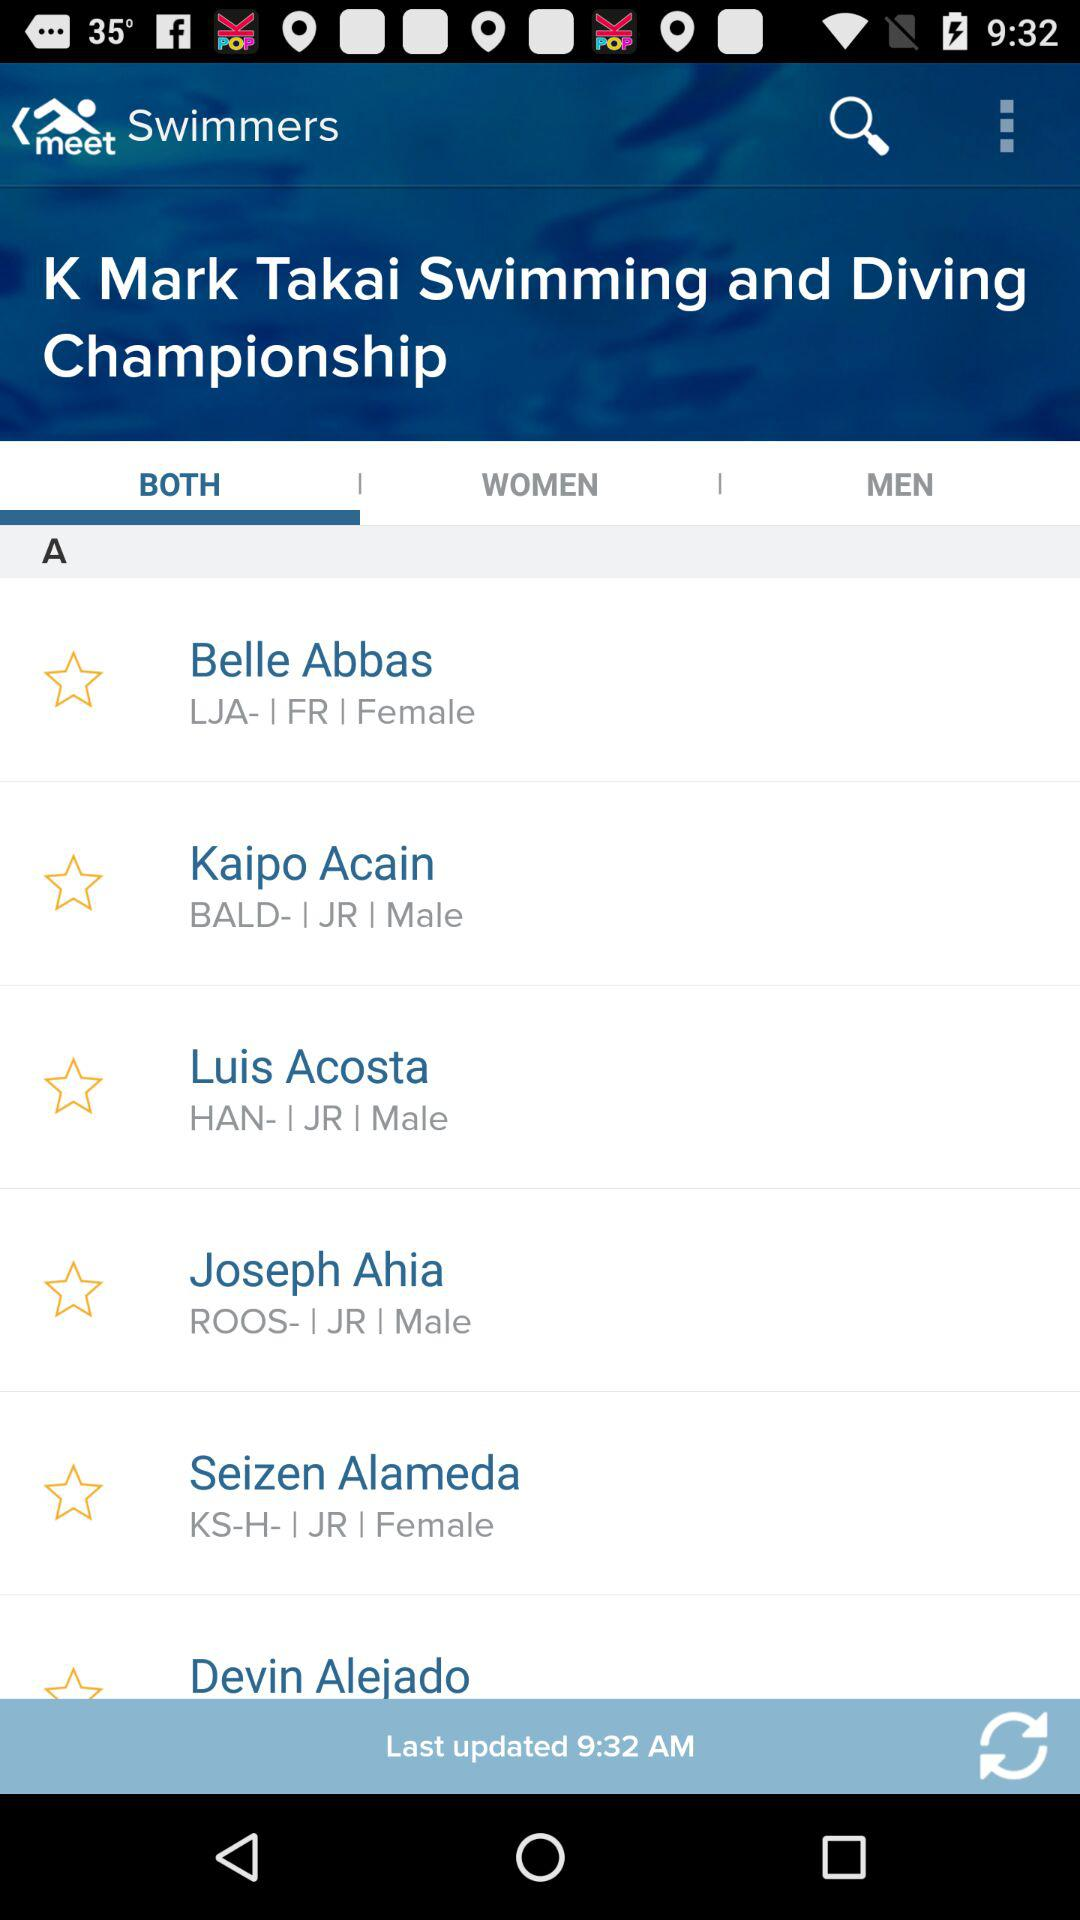Is Belle Abbas male or female? Belle Abbas is female. 